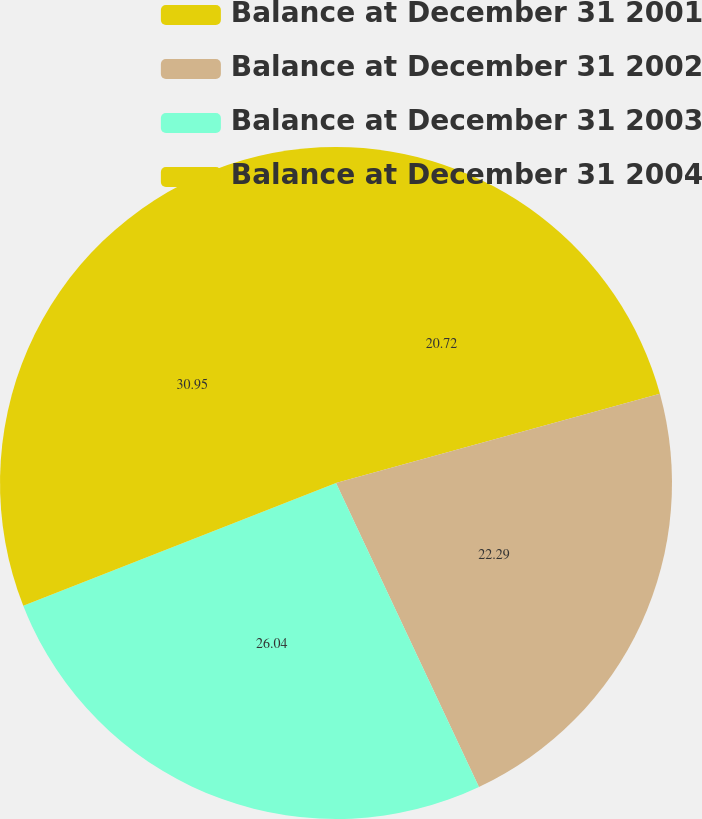<chart> <loc_0><loc_0><loc_500><loc_500><pie_chart><fcel>Balance at December 31 2001<fcel>Balance at December 31 2002<fcel>Balance at December 31 2003<fcel>Balance at December 31 2004<nl><fcel>20.72%<fcel>22.29%<fcel>26.04%<fcel>30.96%<nl></chart> 